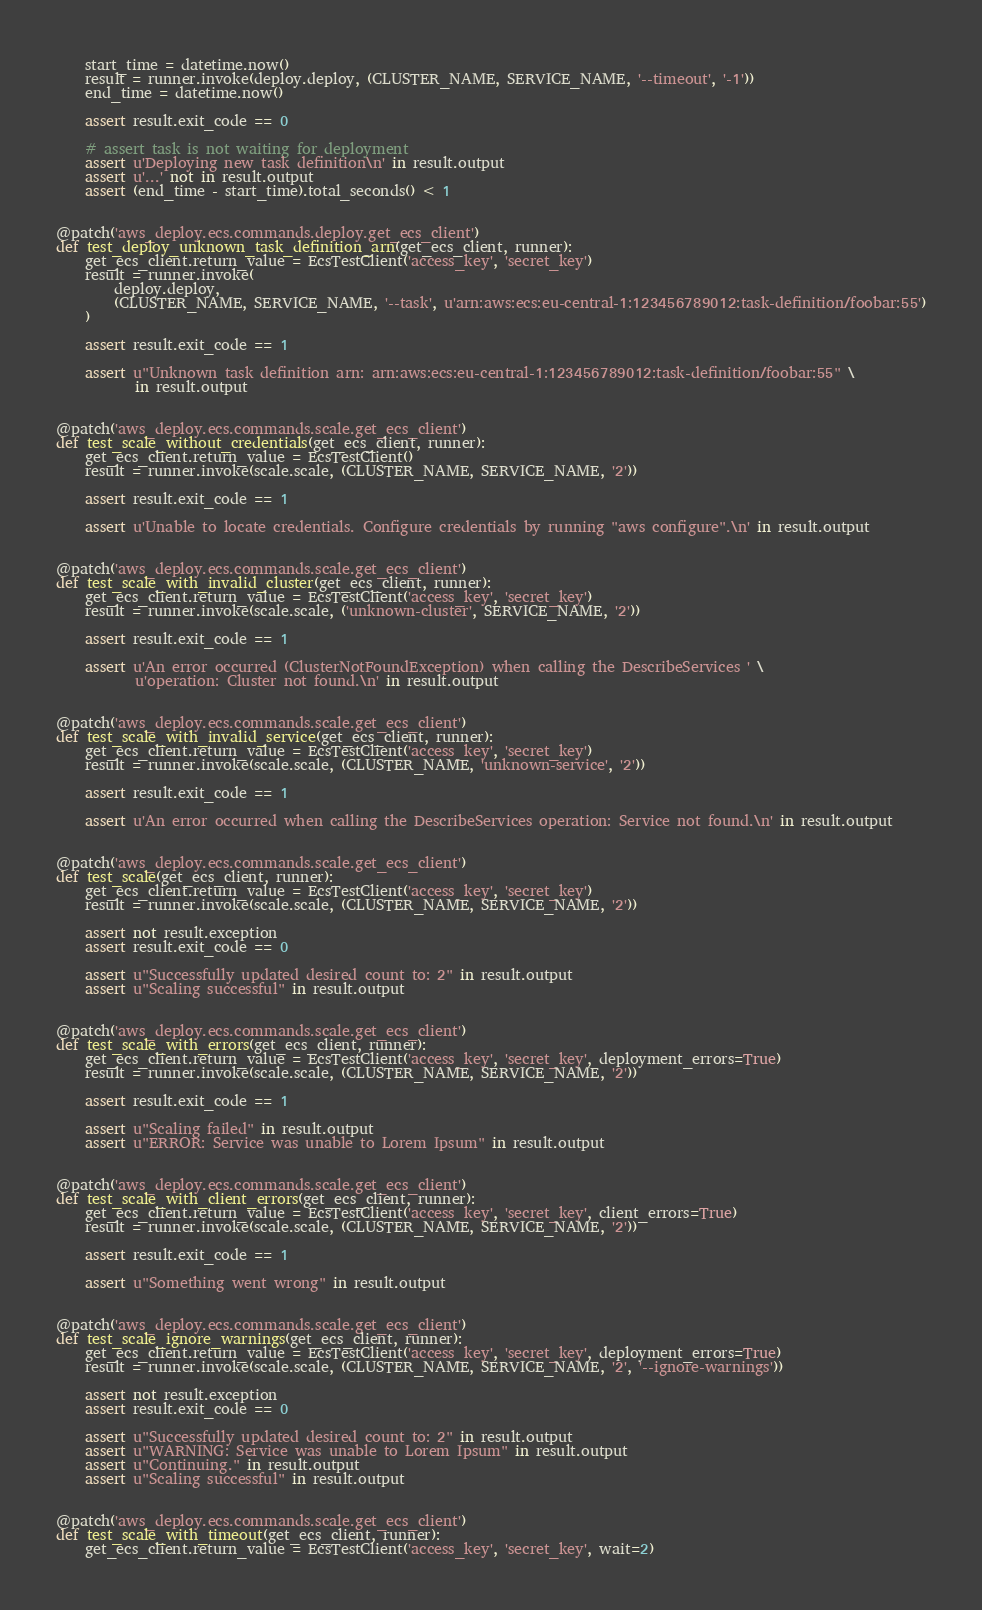<code> <loc_0><loc_0><loc_500><loc_500><_Python_>
    start_time = datetime.now()
    result = runner.invoke(deploy.deploy, (CLUSTER_NAME, SERVICE_NAME, '--timeout', '-1'))
    end_time = datetime.now()

    assert result.exit_code == 0

    # assert task is not waiting for deployment
    assert u'Deploying new task definition\n' in result.output
    assert u'...' not in result.output
    assert (end_time - start_time).total_seconds() < 1


@patch('aws_deploy.ecs.commands.deploy.get_ecs_client')
def test_deploy_unknown_task_definition_arn(get_ecs_client, runner):
    get_ecs_client.return_value = EcsTestClient('access_key', 'secret_key')
    result = runner.invoke(
        deploy.deploy,
        (CLUSTER_NAME, SERVICE_NAME, '--task', u'arn:aws:ecs:eu-central-1:123456789012:task-definition/foobar:55')
    )

    assert result.exit_code == 1

    assert u"Unknown task definition arn: arn:aws:ecs:eu-central-1:123456789012:task-definition/foobar:55" \
           in result.output


@patch('aws_deploy.ecs.commands.scale.get_ecs_client')
def test_scale_without_credentials(get_ecs_client, runner):
    get_ecs_client.return_value = EcsTestClient()
    result = runner.invoke(scale.scale, (CLUSTER_NAME, SERVICE_NAME, '2'))

    assert result.exit_code == 1

    assert u'Unable to locate credentials. Configure credentials by running "aws configure".\n' in result.output


@patch('aws_deploy.ecs.commands.scale.get_ecs_client')
def test_scale_with_invalid_cluster(get_ecs_client, runner):
    get_ecs_client.return_value = EcsTestClient('access_key', 'secret_key')
    result = runner.invoke(scale.scale, ('unknown-cluster', SERVICE_NAME, '2'))

    assert result.exit_code == 1

    assert u'An error occurred (ClusterNotFoundException) when calling the DescribeServices ' \
           u'operation: Cluster not found.\n' in result.output


@patch('aws_deploy.ecs.commands.scale.get_ecs_client')
def test_scale_with_invalid_service(get_ecs_client, runner):
    get_ecs_client.return_value = EcsTestClient('access_key', 'secret_key')
    result = runner.invoke(scale.scale, (CLUSTER_NAME, 'unknown-service', '2'))

    assert result.exit_code == 1

    assert u'An error occurred when calling the DescribeServices operation: Service not found.\n' in result.output


@patch('aws_deploy.ecs.commands.scale.get_ecs_client')
def test_scale(get_ecs_client, runner):
    get_ecs_client.return_value = EcsTestClient('access_key', 'secret_key')
    result = runner.invoke(scale.scale, (CLUSTER_NAME, SERVICE_NAME, '2'))

    assert not result.exception
    assert result.exit_code == 0

    assert u"Successfully updated desired count to: 2" in result.output
    assert u"Scaling successful" in result.output


@patch('aws_deploy.ecs.commands.scale.get_ecs_client')
def test_scale_with_errors(get_ecs_client, runner):
    get_ecs_client.return_value = EcsTestClient('access_key', 'secret_key', deployment_errors=True)
    result = runner.invoke(scale.scale, (CLUSTER_NAME, SERVICE_NAME, '2'))

    assert result.exit_code == 1

    assert u"Scaling failed" in result.output
    assert u"ERROR: Service was unable to Lorem Ipsum" in result.output


@patch('aws_deploy.ecs.commands.scale.get_ecs_client')
def test_scale_with_client_errors(get_ecs_client, runner):
    get_ecs_client.return_value = EcsTestClient('access_key', 'secret_key', client_errors=True)
    result = runner.invoke(scale.scale, (CLUSTER_NAME, SERVICE_NAME, '2'))

    assert result.exit_code == 1

    assert u"Something went wrong" in result.output


@patch('aws_deploy.ecs.commands.scale.get_ecs_client')
def test_scale_ignore_warnings(get_ecs_client, runner):
    get_ecs_client.return_value = EcsTestClient('access_key', 'secret_key', deployment_errors=True)
    result = runner.invoke(scale.scale, (CLUSTER_NAME, SERVICE_NAME, '2', '--ignore-warnings'))

    assert not result.exception
    assert result.exit_code == 0

    assert u"Successfully updated desired count to: 2" in result.output
    assert u"WARNING: Service was unable to Lorem Ipsum" in result.output
    assert u"Continuing." in result.output
    assert u"Scaling successful" in result.output


@patch('aws_deploy.ecs.commands.scale.get_ecs_client')
def test_scale_with_timeout(get_ecs_client, runner):
    get_ecs_client.return_value = EcsTestClient('access_key', 'secret_key', wait=2)</code> 